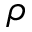<formula> <loc_0><loc_0><loc_500><loc_500>\rho</formula> 